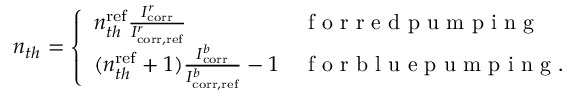Convert formula to latex. <formula><loc_0><loc_0><loc_500><loc_500>\begin{array} { r } { n _ { t h } = \left \{ \begin{array} { l l } { n _ { t h } ^ { r e f } \frac { I _ { c o r r } ^ { r } } { I _ { c o r r , r e f } ^ { r } } } & { f o r r e d p u m p i n g } \\ { ( n _ { t h } ^ { r e f } + 1 ) \frac { I _ { c o r r } ^ { b } } { I _ { c o r r , r e f } ^ { b } } - 1 } & { f o r b l u e p u m p i n g . } \end{array} } \end{array}</formula> 